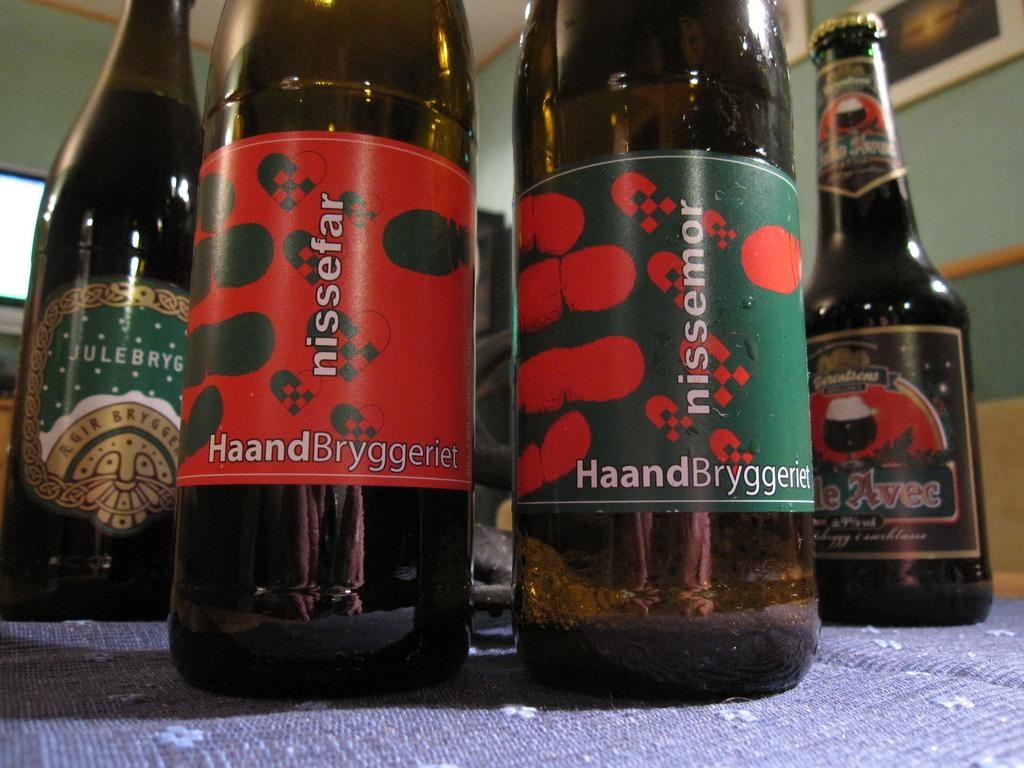Provide a one-sentence caption for the provided image. Four beer bottles sit on a blue tablecloth, two of the bottles are labeled as Nissefar. 